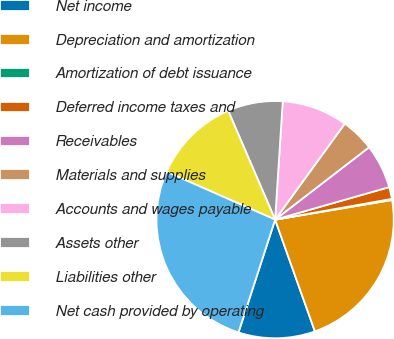Convert chart to OTSL. <chart><loc_0><loc_0><loc_500><loc_500><pie_chart><fcel>Net income<fcel>Depreciation and amortization<fcel>Amortization of debt issuance<fcel>Deferred income taxes and<fcel>Receivables<fcel>Materials and supplies<fcel>Accounts and wages payable<fcel>Assets other<fcel>Liabilities other<fcel>Net cash provided by operating<nl><fcel>10.44%<fcel>22.21%<fcel>0.15%<fcel>1.62%<fcel>6.03%<fcel>4.56%<fcel>8.97%<fcel>7.5%<fcel>11.91%<fcel>26.62%<nl></chart> 